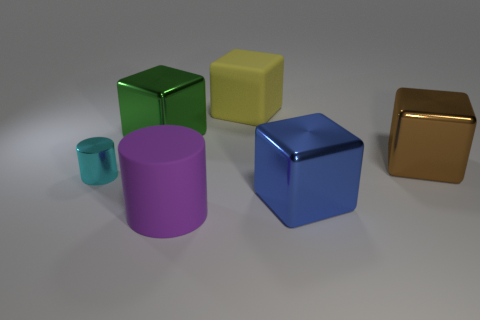Add 2 big cylinders. How many objects exist? 8 Subtract all cylinders. How many objects are left? 4 Add 1 purple matte cylinders. How many purple matte cylinders are left? 2 Add 1 large cyan metal spheres. How many large cyan metal spheres exist? 1 Subtract 0 blue cylinders. How many objects are left? 6 Subtract all small cyan shiny cubes. Subtract all large yellow things. How many objects are left? 5 